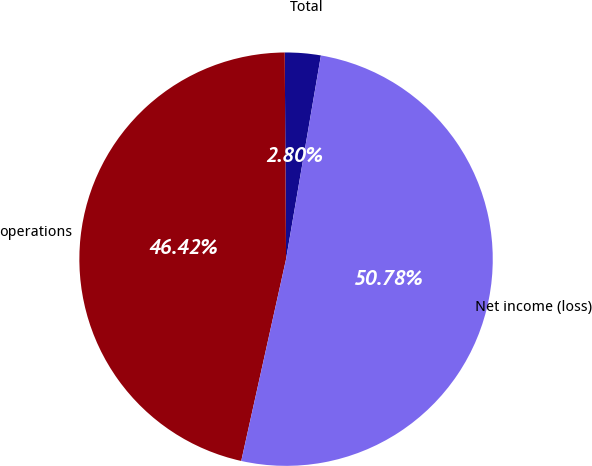<chart> <loc_0><loc_0><loc_500><loc_500><pie_chart><fcel>Total<fcel>operations<fcel>Net income (loss)<nl><fcel>2.8%<fcel>46.42%<fcel>50.78%<nl></chart> 